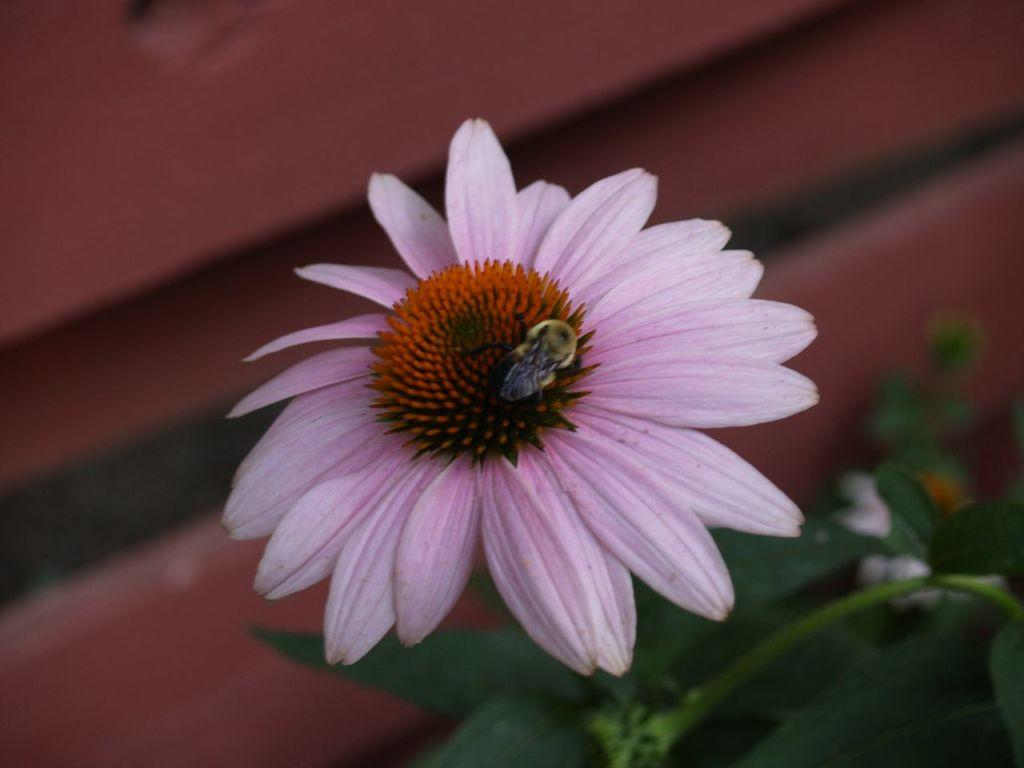What is the main subject of the image? There is a flower in the image. Can you describe the colors of the flower? The flower has pink and orange colors. What else can be seen in the image besides the flower? There is an insect in the image. What is visible in the background of the image? The background of the image includes leaves. What is the color of the background? The background color is brown. What type of pan is being used to cook the star in the image? There is no pan or star present in the image; it features a flower with an insect in a background of leaves. 